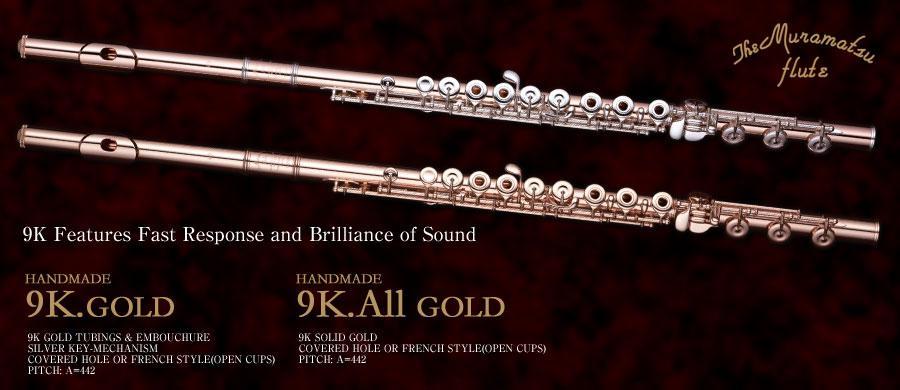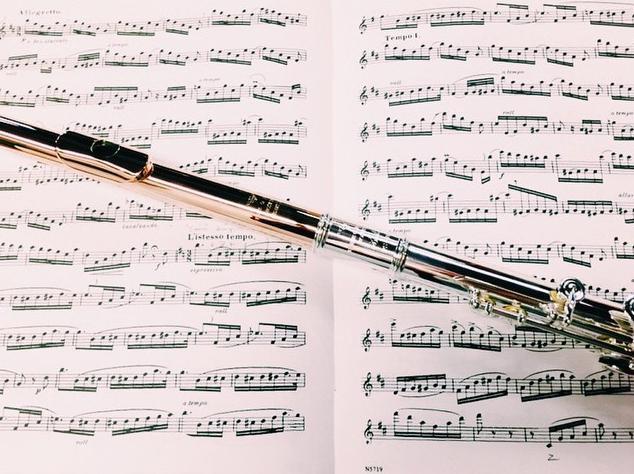The first image is the image on the left, the second image is the image on the right. Given the left and right images, does the statement "All the flutes are assembled." hold true? Answer yes or no. Yes. The first image is the image on the left, the second image is the image on the right. Considering the images on both sides, is "One image shows a shiny pale gold flute in parts inside an open case." valid? Answer yes or no. No. 